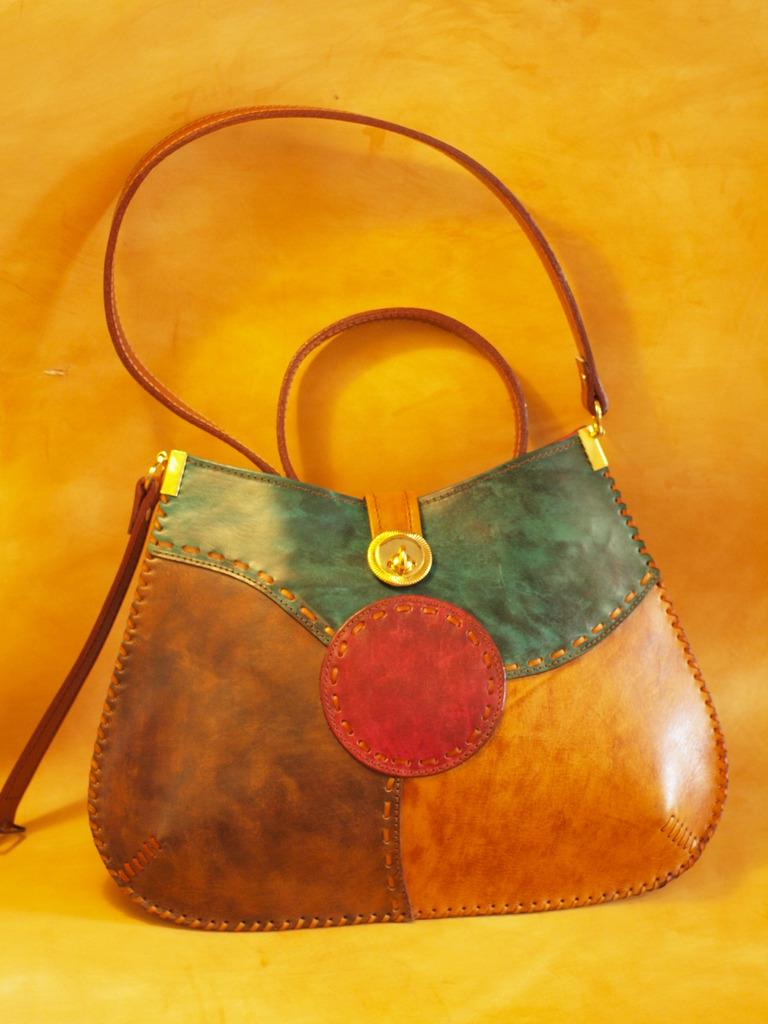What type of object is the main subject of the image? There is a colorful bag in the image. Can you describe the appearance of the bag? The bag is colorful, but no specific colors are mentioned in the facts. What might the bag be used for? The purpose of the bag cannot be determined from the facts, but it could be used for carrying items or as a fashion accessory. How many eyes can be seen on the bag in the image? There are no eyes visible on the bag in the image, as it is an inanimate object and does not have eyes. 